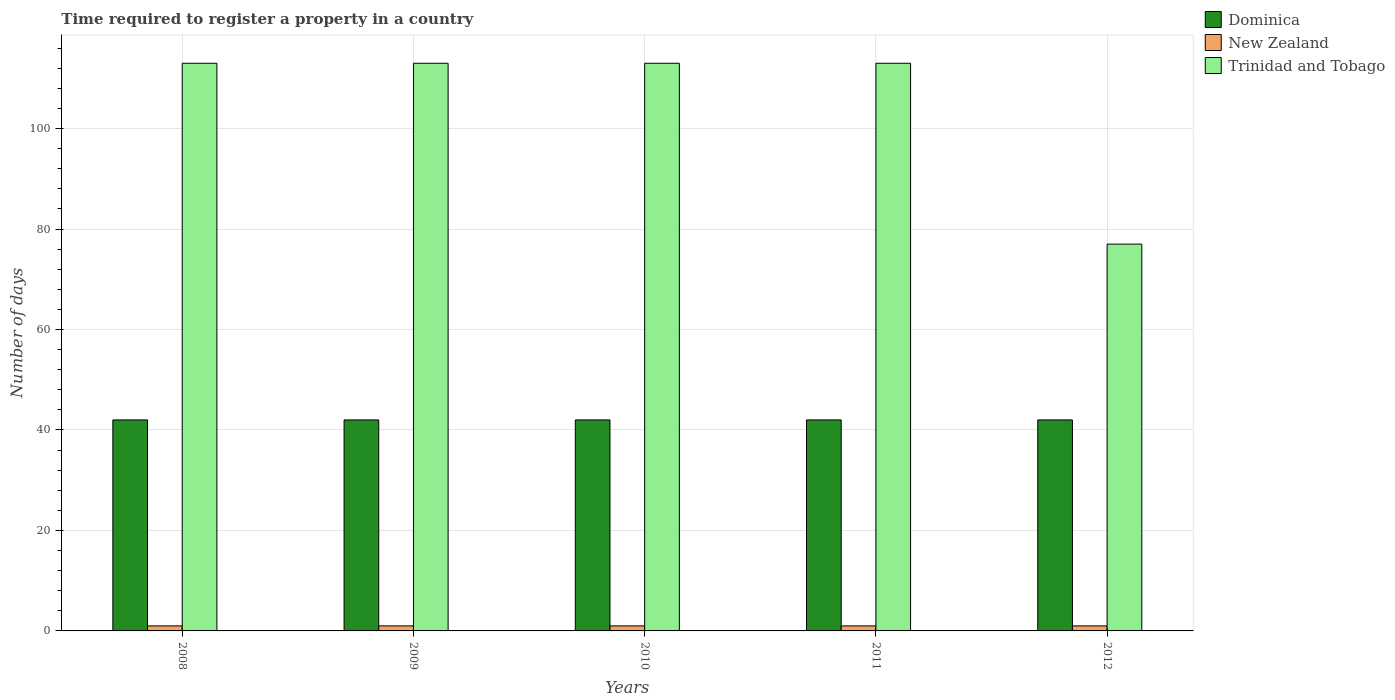How many groups of bars are there?
Your answer should be very brief. 5. Are the number of bars per tick equal to the number of legend labels?
Your response must be concise. Yes. Are the number of bars on each tick of the X-axis equal?
Your answer should be very brief. Yes. How many bars are there on the 2nd tick from the left?
Make the answer very short. 3. What is the label of the 4th group of bars from the left?
Keep it short and to the point. 2011. In how many cases, is the number of bars for a given year not equal to the number of legend labels?
Ensure brevity in your answer.  0. What is the number of days required to register a property in Trinidad and Tobago in 2009?
Your response must be concise. 113. Across all years, what is the maximum number of days required to register a property in Trinidad and Tobago?
Make the answer very short. 113. Across all years, what is the minimum number of days required to register a property in Dominica?
Ensure brevity in your answer.  42. In which year was the number of days required to register a property in Trinidad and Tobago minimum?
Give a very brief answer. 2012. What is the total number of days required to register a property in New Zealand in the graph?
Provide a succinct answer. 5. What is the difference between the number of days required to register a property in Dominica in 2010 and that in 2011?
Offer a very short reply. 0. What is the difference between the number of days required to register a property in Trinidad and Tobago in 2011 and the number of days required to register a property in New Zealand in 2012?
Provide a succinct answer. 112. What is the ratio of the number of days required to register a property in Trinidad and Tobago in 2011 to that in 2012?
Provide a succinct answer. 1.47. Is the number of days required to register a property in Dominica in 2008 less than that in 2011?
Offer a terse response. No. What is the difference between the highest and the second highest number of days required to register a property in New Zealand?
Offer a very short reply. 0. Is the sum of the number of days required to register a property in New Zealand in 2010 and 2012 greater than the maximum number of days required to register a property in Trinidad and Tobago across all years?
Keep it short and to the point. No. What does the 1st bar from the left in 2011 represents?
Offer a very short reply. Dominica. What does the 1st bar from the right in 2008 represents?
Your answer should be very brief. Trinidad and Tobago. Are all the bars in the graph horizontal?
Provide a succinct answer. No. What is the difference between two consecutive major ticks on the Y-axis?
Keep it short and to the point. 20. Does the graph contain any zero values?
Give a very brief answer. No. Does the graph contain grids?
Offer a very short reply. Yes. How many legend labels are there?
Your answer should be compact. 3. What is the title of the graph?
Provide a short and direct response. Time required to register a property in a country. What is the label or title of the X-axis?
Offer a terse response. Years. What is the label or title of the Y-axis?
Your response must be concise. Number of days. What is the Number of days in New Zealand in 2008?
Ensure brevity in your answer.  1. What is the Number of days of Trinidad and Tobago in 2008?
Give a very brief answer. 113. What is the Number of days in Dominica in 2009?
Ensure brevity in your answer.  42. What is the Number of days in Trinidad and Tobago in 2009?
Offer a terse response. 113. What is the Number of days of Dominica in 2010?
Keep it short and to the point. 42. What is the Number of days of New Zealand in 2010?
Offer a terse response. 1. What is the Number of days in Trinidad and Tobago in 2010?
Your answer should be very brief. 113. What is the Number of days of Trinidad and Tobago in 2011?
Make the answer very short. 113. What is the Number of days of Dominica in 2012?
Offer a terse response. 42. What is the Number of days in New Zealand in 2012?
Make the answer very short. 1. Across all years, what is the maximum Number of days in New Zealand?
Keep it short and to the point. 1. Across all years, what is the maximum Number of days in Trinidad and Tobago?
Ensure brevity in your answer.  113. Across all years, what is the minimum Number of days of Trinidad and Tobago?
Ensure brevity in your answer.  77. What is the total Number of days in Dominica in the graph?
Provide a succinct answer. 210. What is the total Number of days of Trinidad and Tobago in the graph?
Your response must be concise. 529. What is the difference between the Number of days in Dominica in 2008 and that in 2009?
Offer a terse response. 0. What is the difference between the Number of days of Trinidad and Tobago in 2008 and that in 2009?
Keep it short and to the point. 0. What is the difference between the Number of days in Dominica in 2008 and that in 2010?
Your response must be concise. 0. What is the difference between the Number of days of New Zealand in 2008 and that in 2010?
Keep it short and to the point. 0. What is the difference between the Number of days of Dominica in 2008 and that in 2011?
Ensure brevity in your answer.  0. What is the difference between the Number of days in Trinidad and Tobago in 2008 and that in 2012?
Your answer should be compact. 36. What is the difference between the Number of days in Dominica in 2009 and that in 2010?
Your answer should be very brief. 0. What is the difference between the Number of days in Trinidad and Tobago in 2009 and that in 2010?
Keep it short and to the point. 0. What is the difference between the Number of days in Dominica in 2009 and that in 2011?
Ensure brevity in your answer.  0. What is the difference between the Number of days in Trinidad and Tobago in 2009 and that in 2011?
Your answer should be very brief. 0. What is the difference between the Number of days in Dominica in 2009 and that in 2012?
Your response must be concise. 0. What is the difference between the Number of days in New Zealand in 2009 and that in 2012?
Your response must be concise. 0. What is the difference between the Number of days in Dominica in 2010 and that in 2011?
Make the answer very short. 0. What is the difference between the Number of days of New Zealand in 2010 and that in 2011?
Provide a succinct answer. 0. What is the difference between the Number of days in Trinidad and Tobago in 2010 and that in 2011?
Offer a terse response. 0. What is the difference between the Number of days in Dominica in 2010 and that in 2012?
Provide a succinct answer. 0. What is the difference between the Number of days in Trinidad and Tobago in 2010 and that in 2012?
Ensure brevity in your answer.  36. What is the difference between the Number of days of Dominica in 2011 and that in 2012?
Offer a very short reply. 0. What is the difference between the Number of days of Dominica in 2008 and the Number of days of New Zealand in 2009?
Offer a very short reply. 41. What is the difference between the Number of days of Dominica in 2008 and the Number of days of Trinidad and Tobago in 2009?
Offer a terse response. -71. What is the difference between the Number of days of New Zealand in 2008 and the Number of days of Trinidad and Tobago in 2009?
Offer a very short reply. -112. What is the difference between the Number of days in Dominica in 2008 and the Number of days in Trinidad and Tobago in 2010?
Keep it short and to the point. -71. What is the difference between the Number of days of New Zealand in 2008 and the Number of days of Trinidad and Tobago in 2010?
Your answer should be compact. -112. What is the difference between the Number of days of Dominica in 2008 and the Number of days of New Zealand in 2011?
Give a very brief answer. 41. What is the difference between the Number of days of Dominica in 2008 and the Number of days of Trinidad and Tobago in 2011?
Your answer should be very brief. -71. What is the difference between the Number of days of New Zealand in 2008 and the Number of days of Trinidad and Tobago in 2011?
Ensure brevity in your answer.  -112. What is the difference between the Number of days in Dominica in 2008 and the Number of days in New Zealand in 2012?
Ensure brevity in your answer.  41. What is the difference between the Number of days in Dominica in 2008 and the Number of days in Trinidad and Tobago in 2012?
Provide a succinct answer. -35. What is the difference between the Number of days in New Zealand in 2008 and the Number of days in Trinidad and Tobago in 2012?
Your answer should be compact. -76. What is the difference between the Number of days in Dominica in 2009 and the Number of days in Trinidad and Tobago in 2010?
Make the answer very short. -71. What is the difference between the Number of days of New Zealand in 2009 and the Number of days of Trinidad and Tobago in 2010?
Your answer should be compact. -112. What is the difference between the Number of days in Dominica in 2009 and the Number of days in New Zealand in 2011?
Offer a very short reply. 41. What is the difference between the Number of days in Dominica in 2009 and the Number of days in Trinidad and Tobago in 2011?
Your answer should be very brief. -71. What is the difference between the Number of days in New Zealand in 2009 and the Number of days in Trinidad and Tobago in 2011?
Keep it short and to the point. -112. What is the difference between the Number of days in Dominica in 2009 and the Number of days in New Zealand in 2012?
Your response must be concise. 41. What is the difference between the Number of days in Dominica in 2009 and the Number of days in Trinidad and Tobago in 2012?
Keep it short and to the point. -35. What is the difference between the Number of days of New Zealand in 2009 and the Number of days of Trinidad and Tobago in 2012?
Provide a succinct answer. -76. What is the difference between the Number of days of Dominica in 2010 and the Number of days of Trinidad and Tobago in 2011?
Your answer should be very brief. -71. What is the difference between the Number of days in New Zealand in 2010 and the Number of days in Trinidad and Tobago in 2011?
Provide a succinct answer. -112. What is the difference between the Number of days of Dominica in 2010 and the Number of days of New Zealand in 2012?
Offer a terse response. 41. What is the difference between the Number of days of Dominica in 2010 and the Number of days of Trinidad and Tobago in 2012?
Provide a succinct answer. -35. What is the difference between the Number of days in New Zealand in 2010 and the Number of days in Trinidad and Tobago in 2012?
Provide a short and direct response. -76. What is the difference between the Number of days of Dominica in 2011 and the Number of days of New Zealand in 2012?
Your answer should be very brief. 41. What is the difference between the Number of days of Dominica in 2011 and the Number of days of Trinidad and Tobago in 2012?
Make the answer very short. -35. What is the difference between the Number of days in New Zealand in 2011 and the Number of days in Trinidad and Tobago in 2012?
Keep it short and to the point. -76. What is the average Number of days in Dominica per year?
Offer a very short reply. 42. What is the average Number of days in New Zealand per year?
Offer a very short reply. 1. What is the average Number of days of Trinidad and Tobago per year?
Your answer should be very brief. 105.8. In the year 2008, what is the difference between the Number of days in Dominica and Number of days in Trinidad and Tobago?
Give a very brief answer. -71. In the year 2008, what is the difference between the Number of days in New Zealand and Number of days in Trinidad and Tobago?
Provide a succinct answer. -112. In the year 2009, what is the difference between the Number of days in Dominica and Number of days in Trinidad and Tobago?
Give a very brief answer. -71. In the year 2009, what is the difference between the Number of days of New Zealand and Number of days of Trinidad and Tobago?
Your response must be concise. -112. In the year 2010, what is the difference between the Number of days of Dominica and Number of days of Trinidad and Tobago?
Provide a short and direct response. -71. In the year 2010, what is the difference between the Number of days in New Zealand and Number of days in Trinidad and Tobago?
Make the answer very short. -112. In the year 2011, what is the difference between the Number of days in Dominica and Number of days in New Zealand?
Offer a very short reply. 41. In the year 2011, what is the difference between the Number of days in Dominica and Number of days in Trinidad and Tobago?
Provide a succinct answer. -71. In the year 2011, what is the difference between the Number of days of New Zealand and Number of days of Trinidad and Tobago?
Your answer should be compact. -112. In the year 2012, what is the difference between the Number of days in Dominica and Number of days in Trinidad and Tobago?
Provide a short and direct response. -35. In the year 2012, what is the difference between the Number of days in New Zealand and Number of days in Trinidad and Tobago?
Ensure brevity in your answer.  -76. What is the ratio of the Number of days of Dominica in 2008 to that in 2009?
Your answer should be very brief. 1. What is the ratio of the Number of days of Dominica in 2008 to that in 2010?
Ensure brevity in your answer.  1. What is the ratio of the Number of days in Trinidad and Tobago in 2008 to that in 2010?
Keep it short and to the point. 1. What is the ratio of the Number of days of Dominica in 2008 to that in 2011?
Offer a very short reply. 1. What is the ratio of the Number of days of New Zealand in 2008 to that in 2011?
Ensure brevity in your answer.  1. What is the ratio of the Number of days in Trinidad and Tobago in 2008 to that in 2012?
Ensure brevity in your answer.  1.47. What is the ratio of the Number of days in New Zealand in 2009 to that in 2010?
Provide a succinct answer. 1. What is the ratio of the Number of days of Trinidad and Tobago in 2009 to that in 2010?
Give a very brief answer. 1. What is the ratio of the Number of days of Dominica in 2009 to that in 2011?
Provide a succinct answer. 1. What is the ratio of the Number of days of Trinidad and Tobago in 2009 to that in 2012?
Offer a very short reply. 1.47. What is the ratio of the Number of days of Dominica in 2010 to that in 2011?
Ensure brevity in your answer.  1. What is the ratio of the Number of days of New Zealand in 2010 to that in 2011?
Offer a terse response. 1. What is the ratio of the Number of days of Dominica in 2010 to that in 2012?
Provide a succinct answer. 1. What is the ratio of the Number of days in New Zealand in 2010 to that in 2012?
Provide a short and direct response. 1. What is the ratio of the Number of days in Trinidad and Tobago in 2010 to that in 2012?
Provide a succinct answer. 1.47. What is the ratio of the Number of days of Dominica in 2011 to that in 2012?
Ensure brevity in your answer.  1. What is the ratio of the Number of days of Trinidad and Tobago in 2011 to that in 2012?
Offer a very short reply. 1.47. What is the difference between the highest and the lowest Number of days in Dominica?
Provide a short and direct response. 0. What is the difference between the highest and the lowest Number of days in New Zealand?
Offer a very short reply. 0. 